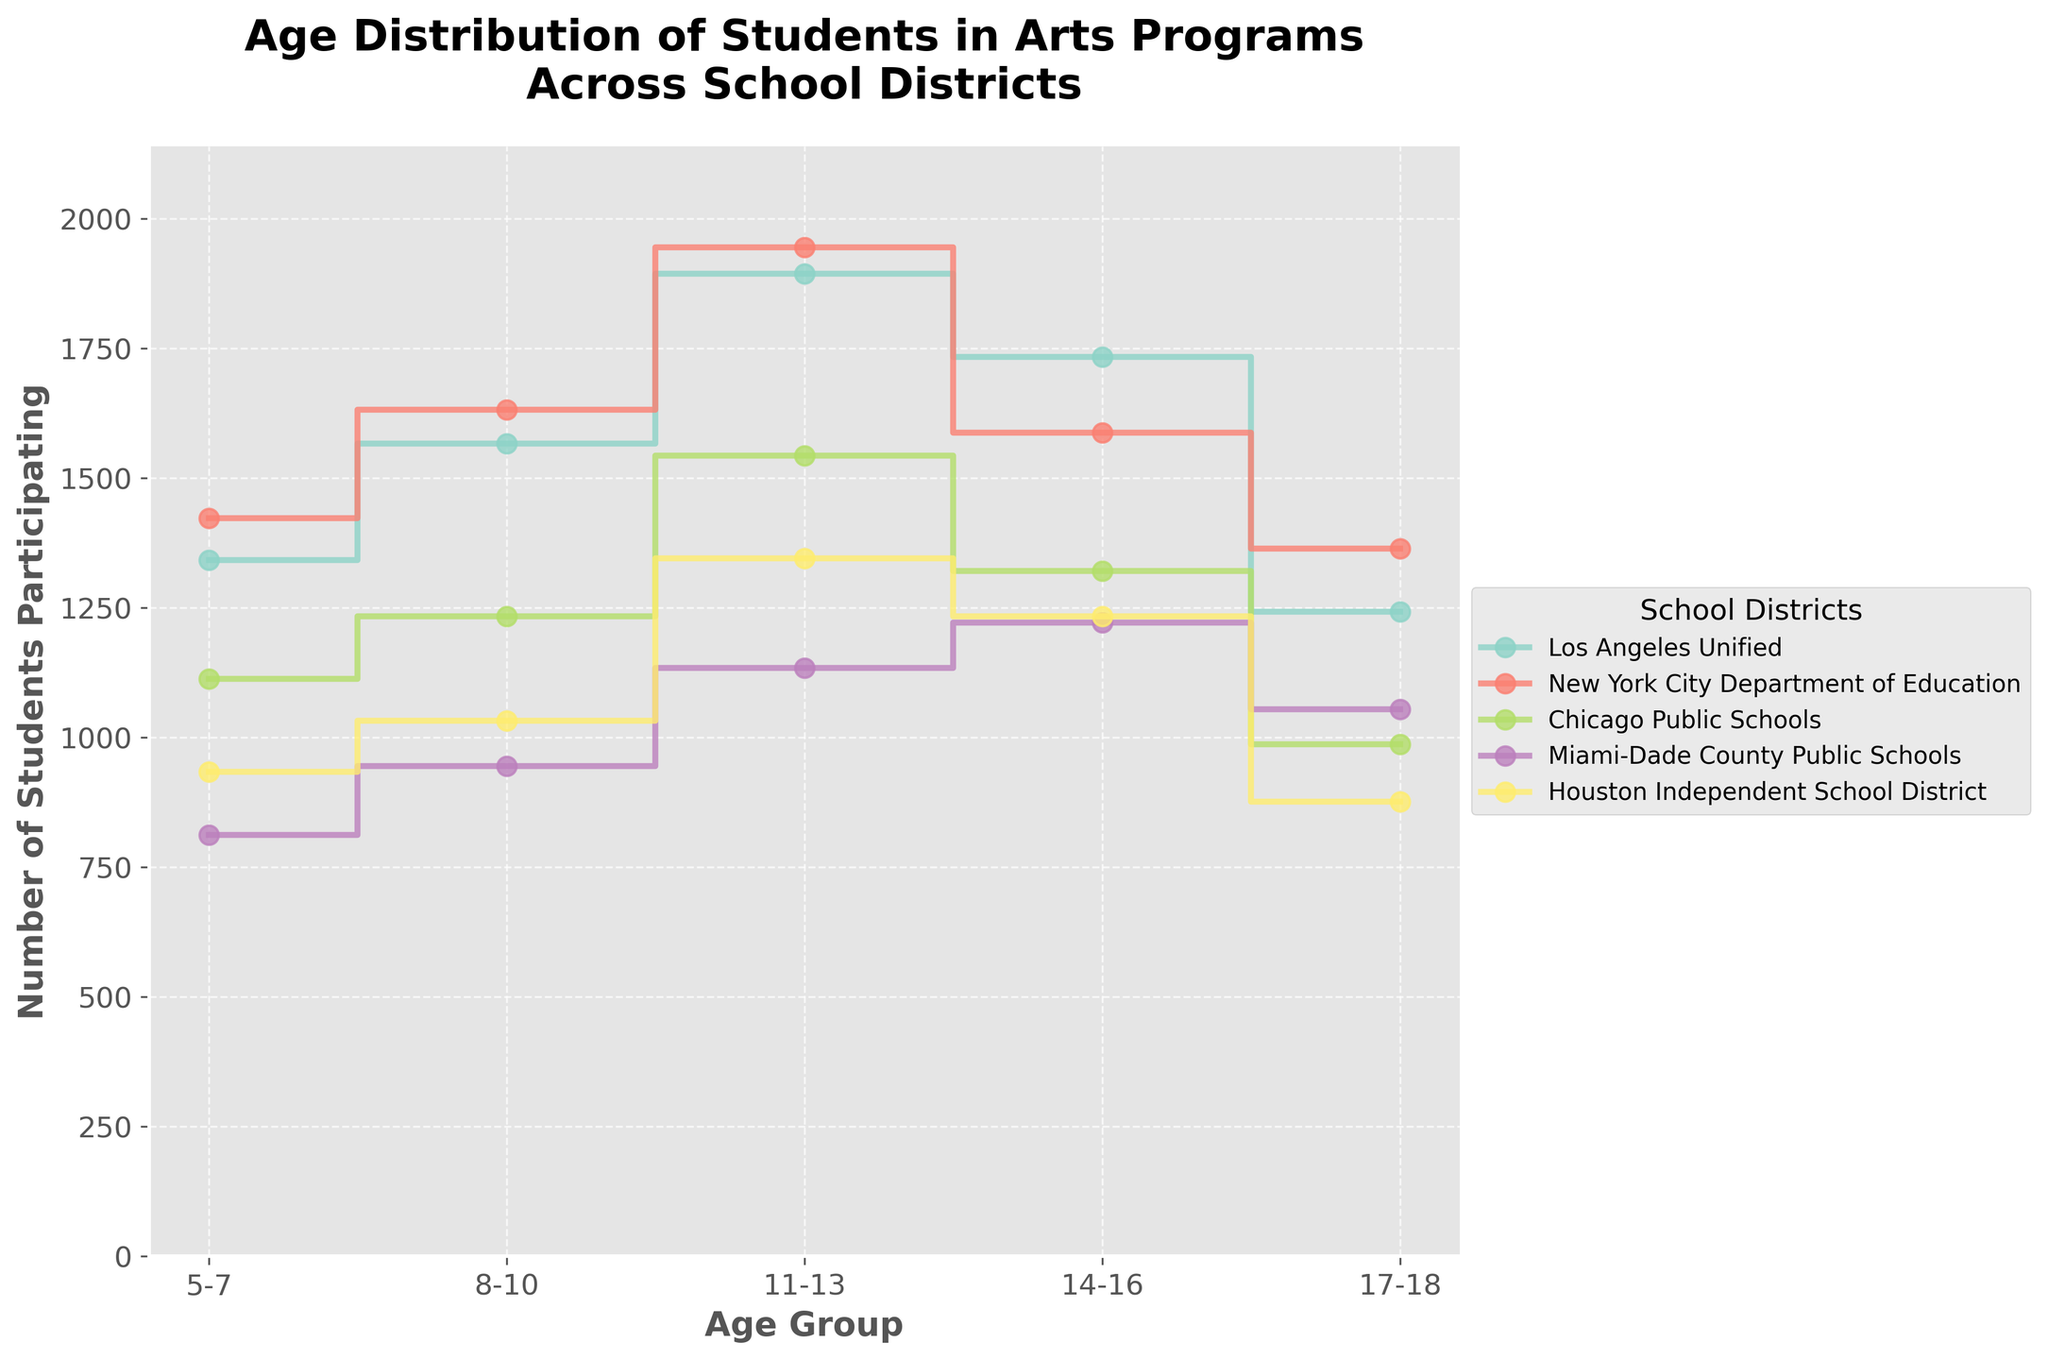Which school district has the highest number of students participating in the 11-13 age group? First, locate the 11-13 age group on the plot. Compare the heights of the stair steps for each school district at this age group. The New York City Department of Education has the highest step.
Answer: New York City Department of Education What is the total number of students participating in arts programs in Los Angeles Unified across all age groups? Sum the heights of the stair steps for all age groups in Los Angeles Unified. The values are 1342 + 1567 + 1894 + 1734 + 1243.
Answer: 7780 Which age group has the highest participation in the Miami-Dade County Public Schools district? Locate the steps for Miami-Dade County Public Schools and identify the age group with the highest step. The 14-16 age group has the highest participation.
Answer: 14-16 By how much does the number of participating students in the 8-10 age group in Houston Independent School District exceed that in Miami-Dade County Public Schools? Subtract the number of participating students in the 8-10 age group in Miami-Dade (945) from that in Houston Independent (1032).
Answer: 87 Which school district has the smallest decrease in the number of participating students between the 14-16 and 17-18 age groups? Check the decrease in participation between 14-16 and 17-18 age groups for each school district and find the smallest difference. For New York City, it's 1588 - 1364 = 224, which is the smallest decrease.
Answer: New York City Department of Education How many school districts have more than 1500 students participating in the 11-13 age group? Identify the number of districts where the step for the 11-13 age group exceeds 1500. Los Angeles Unified, New York City Department of Education, and Chicago Public Schools meet this criterion.
Answer: 3 Compare the participation trend between Los Angeles Unified and Chicago Public Schools across all age groups. Where does the trend start to diverge the most? Observe the alignment and gaps in the stair steps for both districts across the age groups. The trend starts to diverge the most in the 11-13 age group.
Answer: 11-13 What is the average number of participating students across all age groups for the Chicago Public Schools district? Sum the number of participating students for Chicago Public Schools and divide by the number of age groups (5). The sum is 1113 + 1234 + 1543 + 1321 + 987 = 6198, so the average is 6198 / 5.
Answer: 1239.6 Which school district shows a consistent increase in student participation from 5-7 to 14-16 age groups, but a decrease in the 17-18 age group? Check the stair plot trends for each district. New York City Department of Education and Houston Independent School District both show this pattern.
Answer: New York City Department of Education, Houston Independent School District 